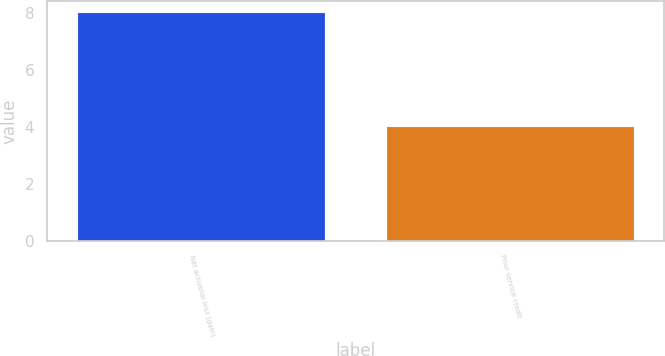Convert chart to OTSL. <chart><loc_0><loc_0><loc_500><loc_500><bar_chart><fcel>Net actuarial loss (gain)<fcel>Prior service credit<nl><fcel>8<fcel>4<nl></chart> 